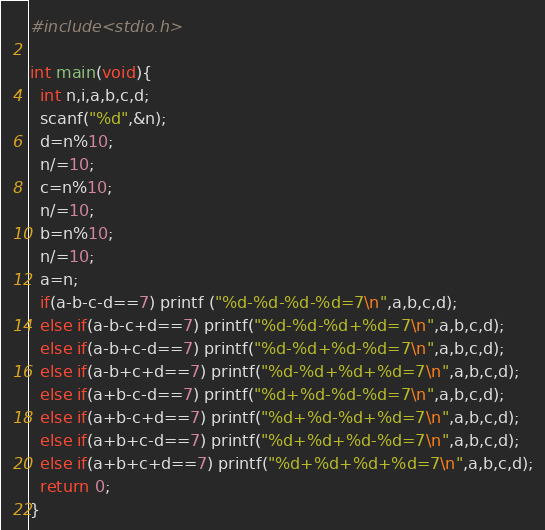<code> <loc_0><loc_0><loc_500><loc_500><_C_>#include<stdio.h>

int main(void){
  int n,i,a,b,c,d;
  scanf("%d",&n);
  d=n%10;
  n/=10;
  c=n%10;
  n/=10;
  b=n%10;
  n/=10;
  a=n;
  if(a-b-c-d==7) printf ("%d-%d-%d-%d=7\n",a,b,c,d);
  else if(a-b-c+d==7) printf("%d-%d-%d+%d=7\n",a,b,c,d);
  else if(a-b+c-d==7) printf("%d-%d+%d-%d=7\n",a,b,c,d);
  else if(a-b+c+d==7) printf("%d-%d+%d+%d=7\n",a,b,c,d);
  else if(a+b-c-d==7) printf("%d+%d-%d-%d=7\n",a,b,c,d);
  else if(a+b-c+d==7) printf("%d+%d-%d+%d=7\n",a,b,c,d);
  else if(a+b+c-d==7) printf("%d+%d+%d-%d=7\n",a,b,c,d);
  else if(a+b+c+d==7) printf("%d+%d+%d+%d=7\n",a,b,c,d);
  return 0;
}</code> 